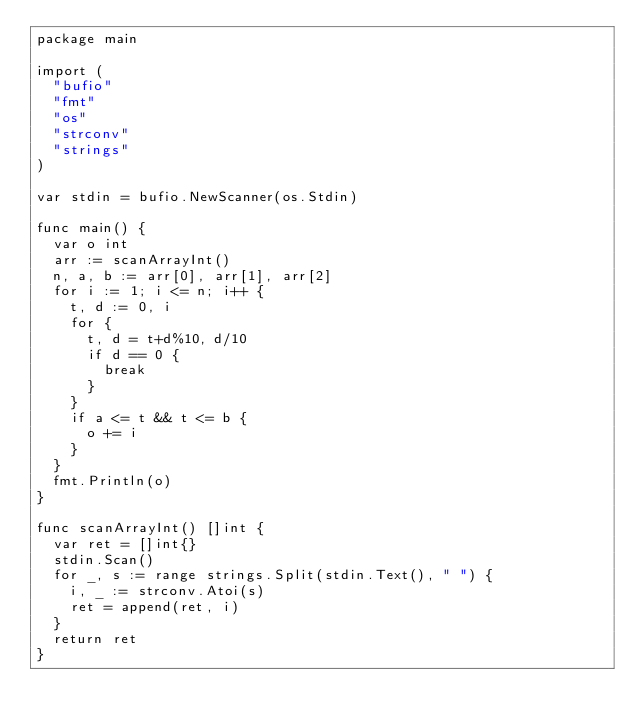<code> <loc_0><loc_0><loc_500><loc_500><_Go_>package main

import (
	"bufio"
	"fmt"
	"os"
	"strconv"
	"strings"
)

var stdin = bufio.NewScanner(os.Stdin)

func main() {
	var o int
	arr := scanArrayInt()
	n, a, b := arr[0], arr[1], arr[2]
	for i := 1; i <= n; i++ {
		t, d := 0, i
		for {
			t, d = t+d%10, d/10
			if d == 0 {
				break
			}
		}
		if a <= t && t <= b {
			o += i
		}
	}
	fmt.Println(o)
}

func scanArrayInt() []int {
	var ret = []int{}
	stdin.Scan()
	for _, s := range strings.Split(stdin.Text(), " ") {
		i, _ := strconv.Atoi(s)
		ret = append(ret, i)
	}
	return ret
}
</code> 